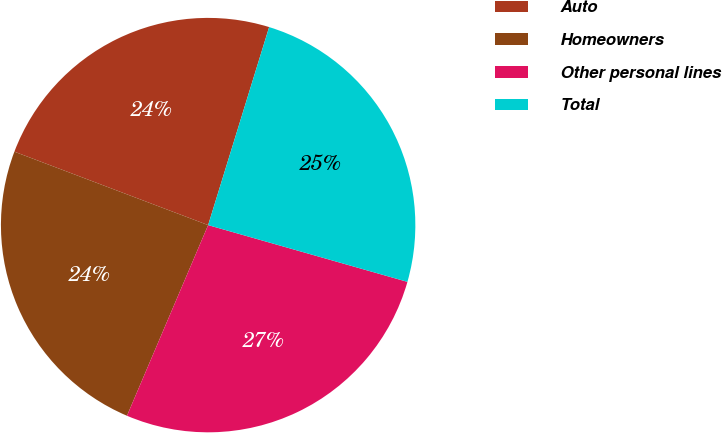Convert chart. <chart><loc_0><loc_0><loc_500><loc_500><pie_chart><fcel>Auto<fcel>Homeowners<fcel>Other personal lines<fcel>Total<nl><fcel>23.99%<fcel>24.36%<fcel>26.99%<fcel>24.66%<nl></chart> 